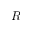<formula> <loc_0><loc_0><loc_500><loc_500>R</formula> 